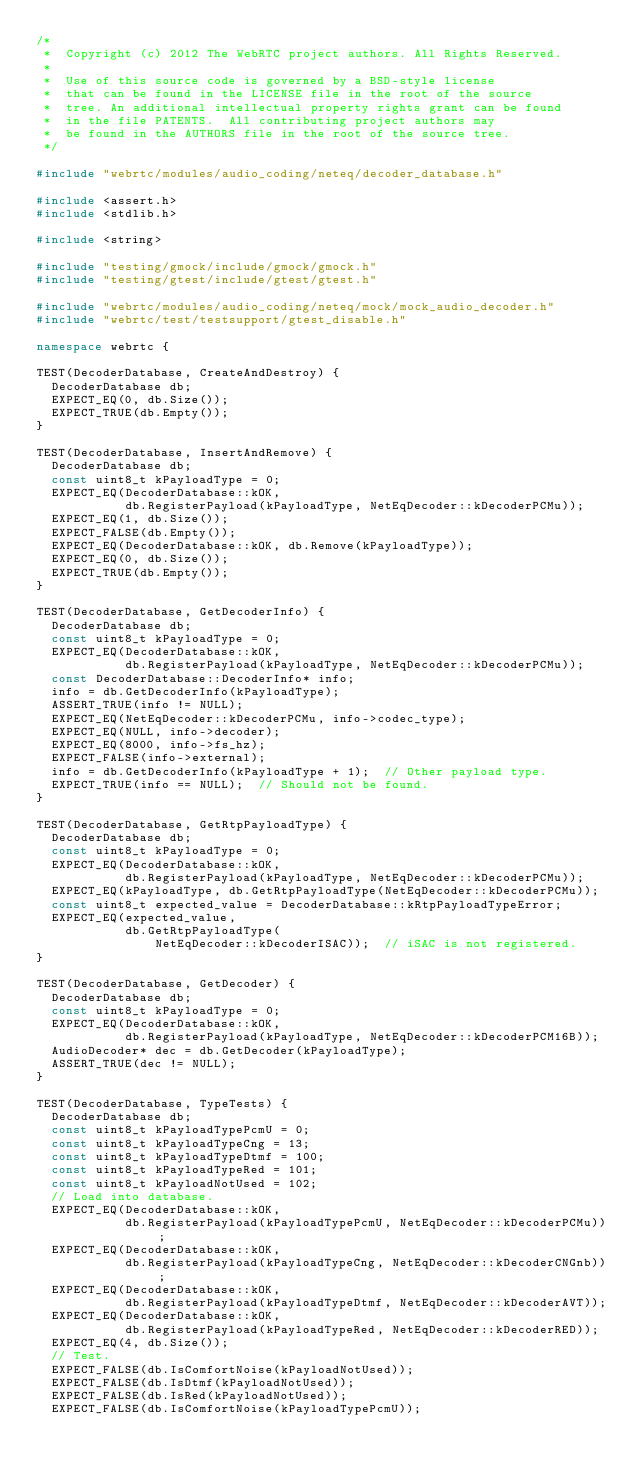<code> <loc_0><loc_0><loc_500><loc_500><_C++_>/*
 *  Copyright (c) 2012 The WebRTC project authors. All Rights Reserved.
 *
 *  Use of this source code is governed by a BSD-style license
 *  that can be found in the LICENSE file in the root of the source
 *  tree. An additional intellectual property rights grant can be found
 *  in the file PATENTS.  All contributing project authors may
 *  be found in the AUTHORS file in the root of the source tree.
 */

#include "webrtc/modules/audio_coding/neteq/decoder_database.h"

#include <assert.h>
#include <stdlib.h>

#include <string>

#include "testing/gmock/include/gmock/gmock.h"
#include "testing/gtest/include/gtest/gtest.h"

#include "webrtc/modules/audio_coding/neteq/mock/mock_audio_decoder.h"
#include "webrtc/test/testsupport/gtest_disable.h"

namespace webrtc {

TEST(DecoderDatabase, CreateAndDestroy) {
  DecoderDatabase db;
  EXPECT_EQ(0, db.Size());
  EXPECT_TRUE(db.Empty());
}

TEST(DecoderDatabase, InsertAndRemove) {
  DecoderDatabase db;
  const uint8_t kPayloadType = 0;
  EXPECT_EQ(DecoderDatabase::kOK,
            db.RegisterPayload(kPayloadType, NetEqDecoder::kDecoderPCMu));
  EXPECT_EQ(1, db.Size());
  EXPECT_FALSE(db.Empty());
  EXPECT_EQ(DecoderDatabase::kOK, db.Remove(kPayloadType));
  EXPECT_EQ(0, db.Size());
  EXPECT_TRUE(db.Empty());
}

TEST(DecoderDatabase, GetDecoderInfo) {
  DecoderDatabase db;
  const uint8_t kPayloadType = 0;
  EXPECT_EQ(DecoderDatabase::kOK,
            db.RegisterPayload(kPayloadType, NetEqDecoder::kDecoderPCMu));
  const DecoderDatabase::DecoderInfo* info;
  info = db.GetDecoderInfo(kPayloadType);
  ASSERT_TRUE(info != NULL);
  EXPECT_EQ(NetEqDecoder::kDecoderPCMu, info->codec_type);
  EXPECT_EQ(NULL, info->decoder);
  EXPECT_EQ(8000, info->fs_hz);
  EXPECT_FALSE(info->external);
  info = db.GetDecoderInfo(kPayloadType + 1);  // Other payload type.
  EXPECT_TRUE(info == NULL);  // Should not be found.
}

TEST(DecoderDatabase, GetRtpPayloadType) {
  DecoderDatabase db;
  const uint8_t kPayloadType = 0;
  EXPECT_EQ(DecoderDatabase::kOK,
            db.RegisterPayload(kPayloadType, NetEqDecoder::kDecoderPCMu));
  EXPECT_EQ(kPayloadType, db.GetRtpPayloadType(NetEqDecoder::kDecoderPCMu));
  const uint8_t expected_value = DecoderDatabase::kRtpPayloadTypeError;
  EXPECT_EQ(expected_value,
            db.GetRtpPayloadType(
                NetEqDecoder::kDecoderISAC));  // iSAC is not registered.
}

TEST(DecoderDatabase, GetDecoder) {
  DecoderDatabase db;
  const uint8_t kPayloadType = 0;
  EXPECT_EQ(DecoderDatabase::kOK,
            db.RegisterPayload(kPayloadType, NetEqDecoder::kDecoderPCM16B));
  AudioDecoder* dec = db.GetDecoder(kPayloadType);
  ASSERT_TRUE(dec != NULL);
}

TEST(DecoderDatabase, TypeTests) {
  DecoderDatabase db;
  const uint8_t kPayloadTypePcmU = 0;
  const uint8_t kPayloadTypeCng = 13;
  const uint8_t kPayloadTypeDtmf = 100;
  const uint8_t kPayloadTypeRed = 101;
  const uint8_t kPayloadNotUsed = 102;
  // Load into database.
  EXPECT_EQ(DecoderDatabase::kOK,
            db.RegisterPayload(kPayloadTypePcmU, NetEqDecoder::kDecoderPCMu));
  EXPECT_EQ(DecoderDatabase::kOK,
            db.RegisterPayload(kPayloadTypeCng, NetEqDecoder::kDecoderCNGnb));
  EXPECT_EQ(DecoderDatabase::kOK,
            db.RegisterPayload(kPayloadTypeDtmf, NetEqDecoder::kDecoderAVT));
  EXPECT_EQ(DecoderDatabase::kOK,
            db.RegisterPayload(kPayloadTypeRed, NetEqDecoder::kDecoderRED));
  EXPECT_EQ(4, db.Size());
  // Test.
  EXPECT_FALSE(db.IsComfortNoise(kPayloadNotUsed));
  EXPECT_FALSE(db.IsDtmf(kPayloadNotUsed));
  EXPECT_FALSE(db.IsRed(kPayloadNotUsed));
  EXPECT_FALSE(db.IsComfortNoise(kPayloadTypePcmU));</code> 